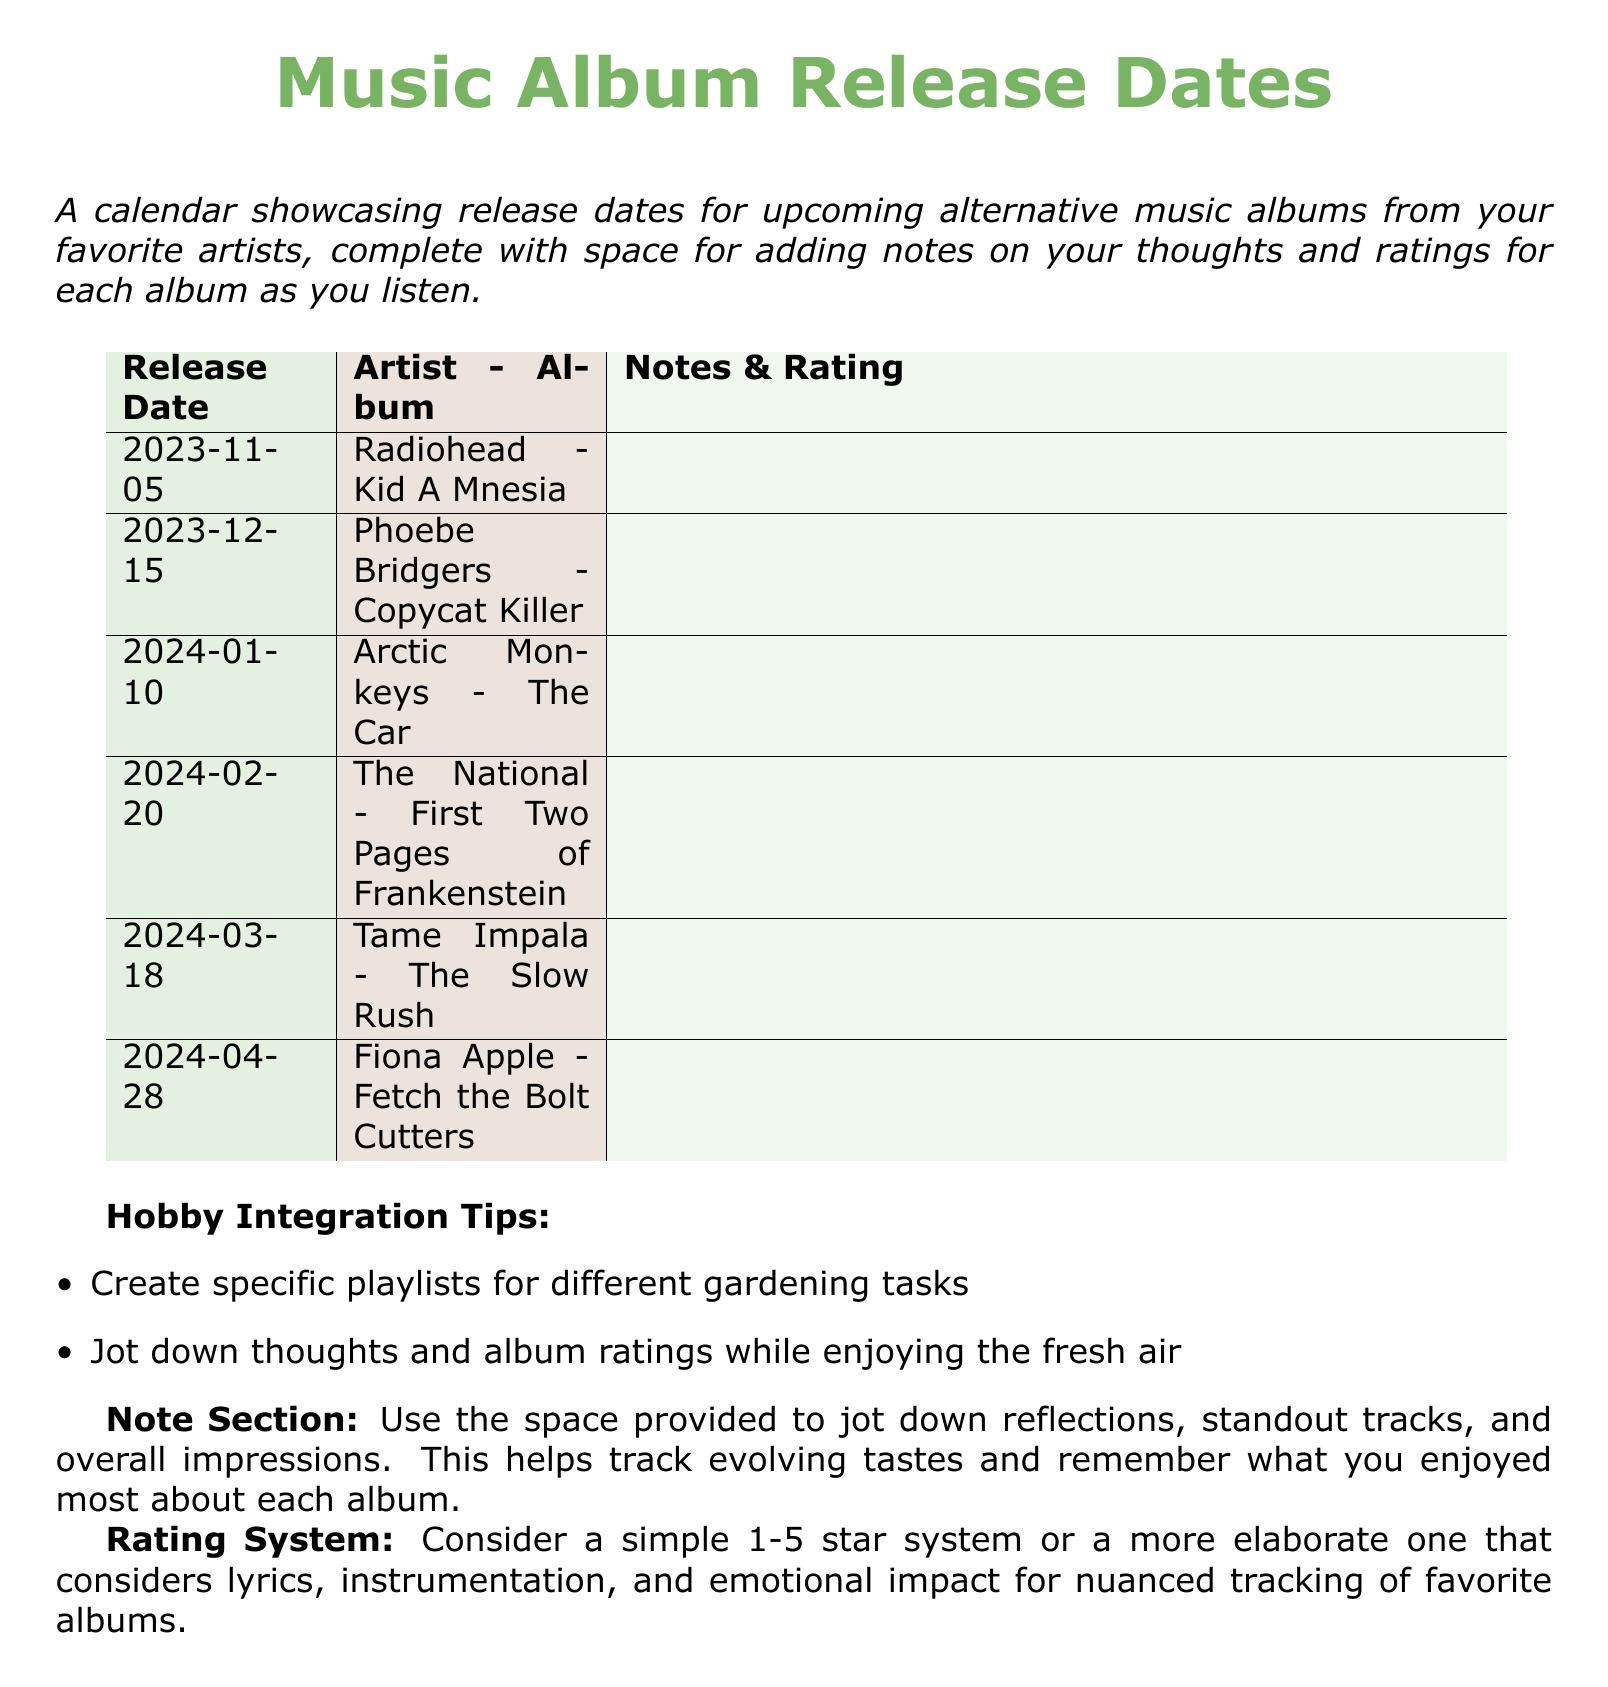What is the release date for Radiohead's album? The release date for Radiohead's album "Kid A Mnesia" is listed in the document as 2023-11-05.
Answer: 2023-11-05 Who is the artist of the album titled "Copycat Killer"? The document provides the album title and artist, which states that "Copycat Killer" is by Phoebe Bridgers.
Answer: Phoebe Bridgers How many albums are listed for release in 2024? Counting the entries in the document, there are five albums scheduled for release in 2024.
Answer: 5 What is the title of the album by The National? The National’s album is titled "First Two Pages of Frankenstein," as per the document.
Answer: First Two Pages of Frankenstein What is the noted space for in the calendar? The calendar includes space for adding notes and ratings for each album after listening, as described in the document.
Answer: Notes & Rating Which artist has an album titled "Fetch the Bolt Cutters"? According to the document, Fiona Apple is the artist for the album "Fetch the Bolt Cutters."
Answer: Fiona Apple What color scheme is used for the release date column? The release date column in the document uses a leaf green light background color.
Answer: Leaf green What is the rating system suggested for evaluating albums? The document suggests using a simple 1-5 star system or a more elaborate system based on various musical elements.
Answer: 1-5 stars or elaborate system What benefit does the document suggest for gardening tasks? The document suggests creating specific playlists for different gardening tasks as a benefit.
Answer: Playlists for gardening tasks 